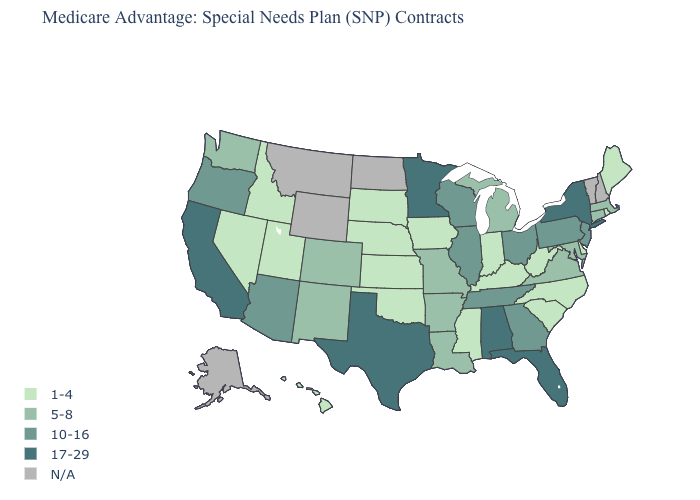Name the states that have a value in the range 10-16?
Be succinct. Arizona, Georgia, Illinois, New Jersey, Ohio, Oregon, Pennsylvania, Tennessee, Wisconsin. Does the first symbol in the legend represent the smallest category?
Concise answer only. Yes. Name the states that have a value in the range 1-4?
Short answer required. Delaware, Hawaii, Iowa, Idaho, Indiana, Kansas, Kentucky, Maine, Mississippi, North Carolina, Nebraska, Nevada, Oklahoma, Rhode Island, South Carolina, South Dakota, Utah, West Virginia. Among the states that border Connecticut , does New York have the highest value?
Concise answer only. Yes. What is the value of Connecticut?
Be succinct. 5-8. Name the states that have a value in the range 5-8?
Be succinct. Arkansas, Colorado, Connecticut, Louisiana, Massachusetts, Maryland, Michigan, Missouri, New Mexico, Virginia, Washington. Is the legend a continuous bar?
Give a very brief answer. No. Among the states that border Virginia , does North Carolina have the highest value?
Keep it brief. No. Which states have the lowest value in the USA?
Short answer required. Delaware, Hawaii, Iowa, Idaho, Indiana, Kansas, Kentucky, Maine, Mississippi, North Carolina, Nebraska, Nevada, Oklahoma, Rhode Island, South Carolina, South Dakota, Utah, West Virginia. Does Delaware have the lowest value in the South?
Concise answer only. Yes. What is the highest value in the Northeast ?
Give a very brief answer. 17-29. Does Indiana have the lowest value in the MidWest?
Answer briefly. Yes. What is the lowest value in states that border Minnesota?
Concise answer only. 1-4. 